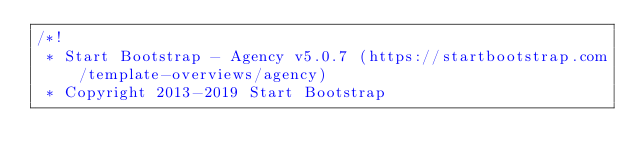<code> <loc_0><loc_0><loc_500><loc_500><_CSS_>/*!
 * Start Bootstrap - Agency v5.0.7 (https://startbootstrap.com/template-overviews/agency)
 * Copyright 2013-2019 Start Bootstrap</code> 